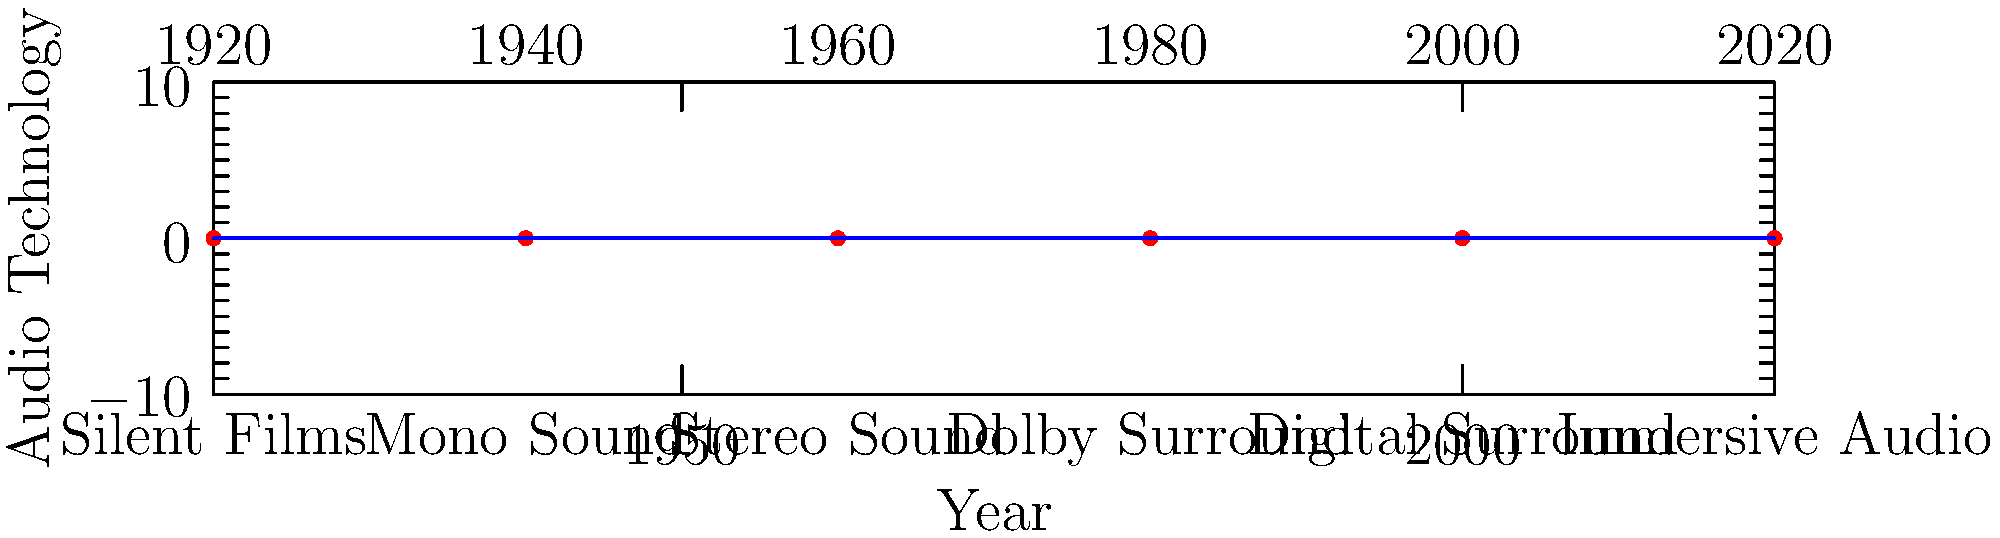Based on the timeline infographic of audio system progression in the Virginia Theatre, which audio technology was likely in use when you first started working at the theater, and what was the most advanced system implemented during your employment? To answer this question, we need to analyze the timeline and consider the typical career span of a theater employee:

1. The timeline shows the progression of audio technologies from 1920 to 2020.
2. As a former employee, you likely worked at the theater for a period within the last 30-40 years.
3. Let's assume you started working in the late 1980s or early 1990s.
4. In the 1980s, the prevalent technology was Dolby Surround.
5. The most recent advancements shown are Digital Surround (around 2000) and Immersive Audio (around 2020).
6. Considering a typical career span, you probably experienced the transition from Dolby Surround to Digital Surround, and possibly the introduction of Immersive Audio.

Therefore, the audio technology likely in use when you started was Dolby Surround, and the most advanced system implemented during your employment would be either Digital Surround or Immersive Audio, depending on how recently you left the theater.
Answer: Dolby Surround at start; Digital Surround or Immersive Audio as most advanced 